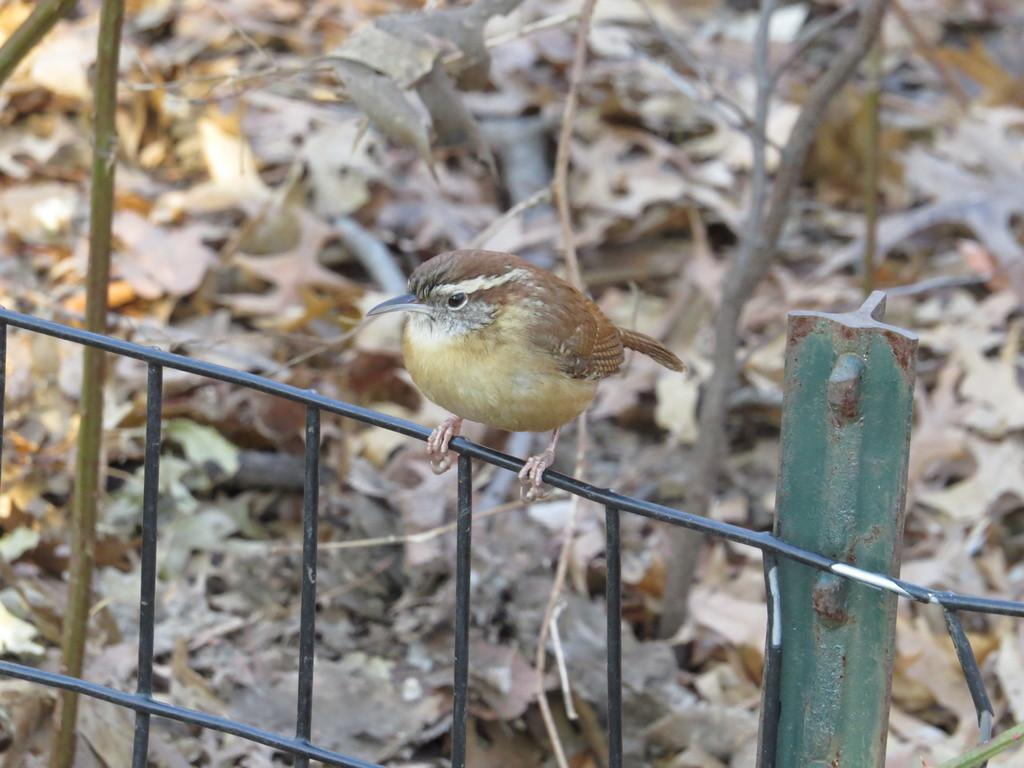What animal can be seen on the fence in the image? There is a bird on the fence in the image. What can be found on the floor in the image? Dry leaves are present on the floor in the image. What type of vegetation is visible in the image? There are plants visible in the image. How many giants are resting in the image? There are no giants present in the image, and therefore no giants can be seen resting. What is the condition of the bird in the image? The provided facts do not give information about the condition of the bird, so we cannot determine its condition from the image. 